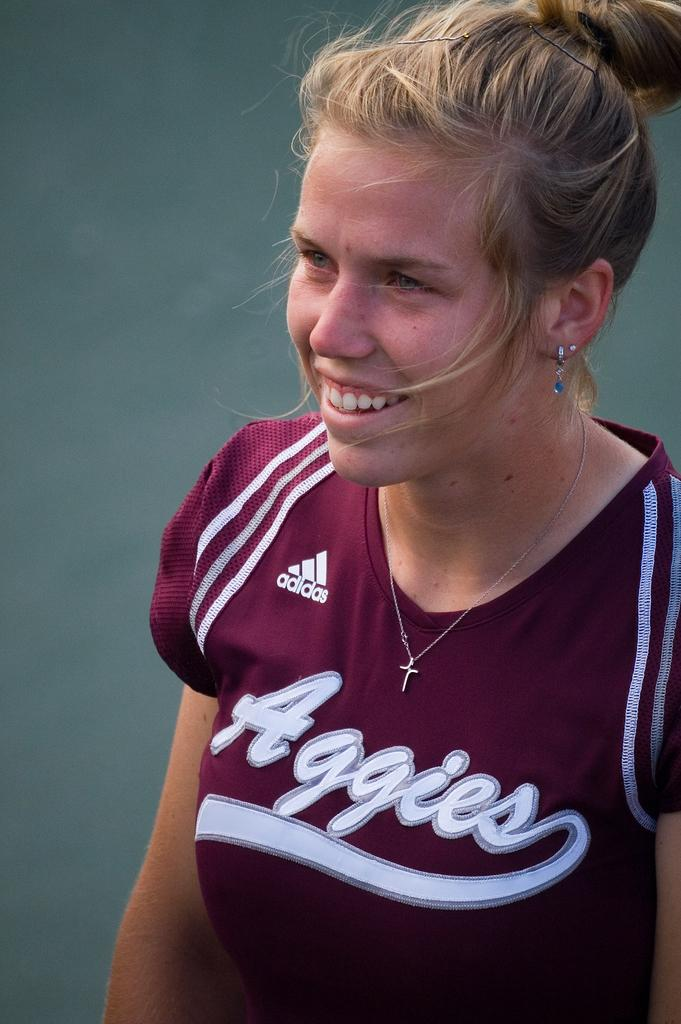<image>
Relay a brief, clear account of the picture shown. A woman in an Aggies shirt wears a cross necklace and silver earrings. 